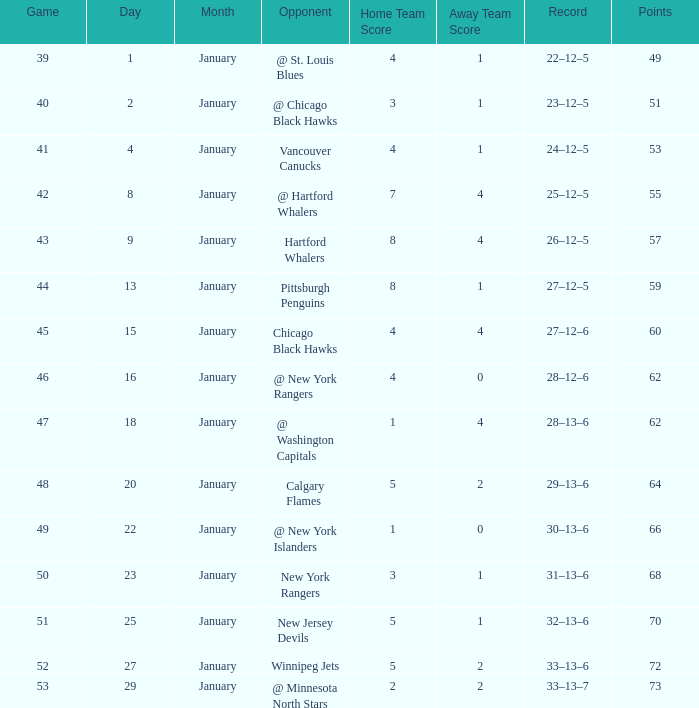Which Points is the lowest one that has a Score of 1–4, and a January smaller than 18? None. 